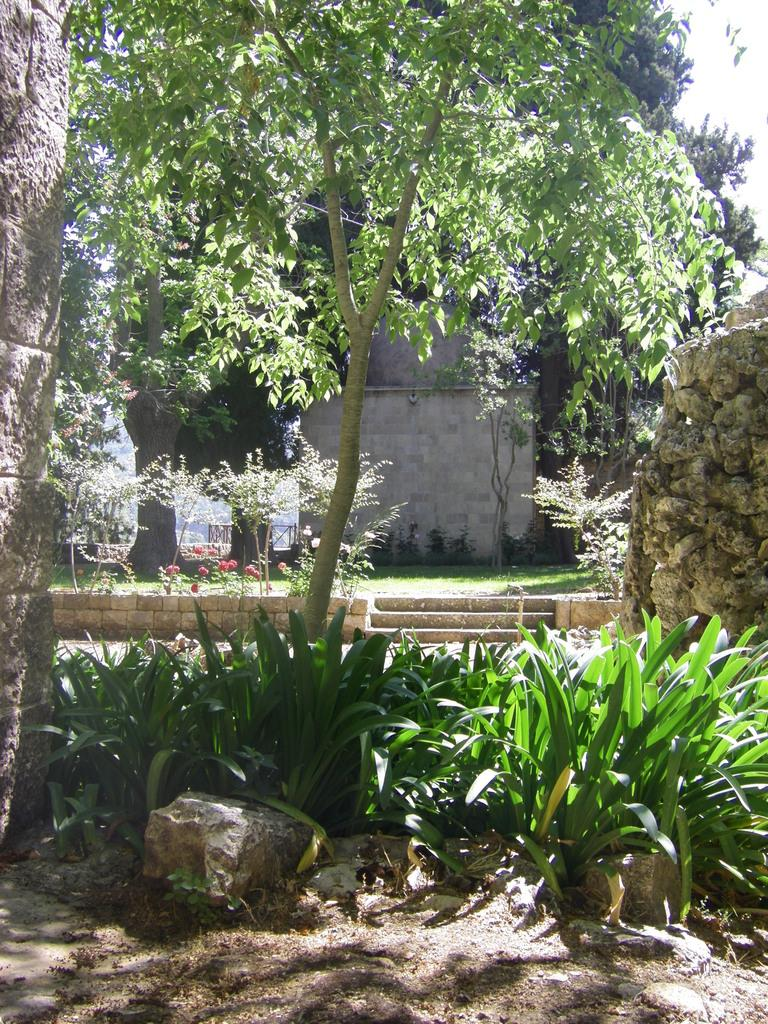What type of vegetation can be seen in the image? There are plants and trees in the image. What other natural elements are present in the image? There are rocks and grass in the image. What man-made structures can be seen in the image? There is a wall and stairs in the image. Can you describe the stone wall in the image? There is a stone wall on the right side of the image. What part of the natural environment is visible in the image? The sky is visible in the image. What type of lace is draped over the shelf in the image? There is no shelf or lace present in the image. What government policies are being discussed in the image? There is no discussion of government policies in the image. 